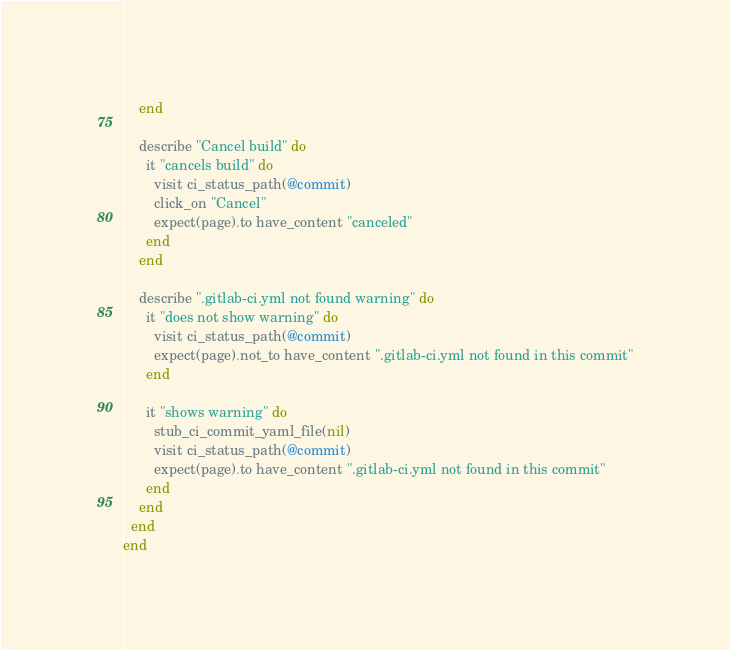<code> <loc_0><loc_0><loc_500><loc_500><_Ruby_>    end

    describe "Cancel build" do
      it "cancels build" do
        visit ci_status_path(@commit)
        click_on "Cancel"
        expect(page).to have_content "canceled"
      end
    end

    describe ".gitlab-ci.yml not found warning" do
      it "does not show warning" do
        visit ci_status_path(@commit)
        expect(page).not_to have_content ".gitlab-ci.yml not found in this commit"
      end

      it "shows warning" do
        stub_ci_commit_yaml_file(nil)
        visit ci_status_path(@commit)
        expect(page).to have_content ".gitlab-ci.yml not found in this commit"
      end
    end
  end
end
</code> 